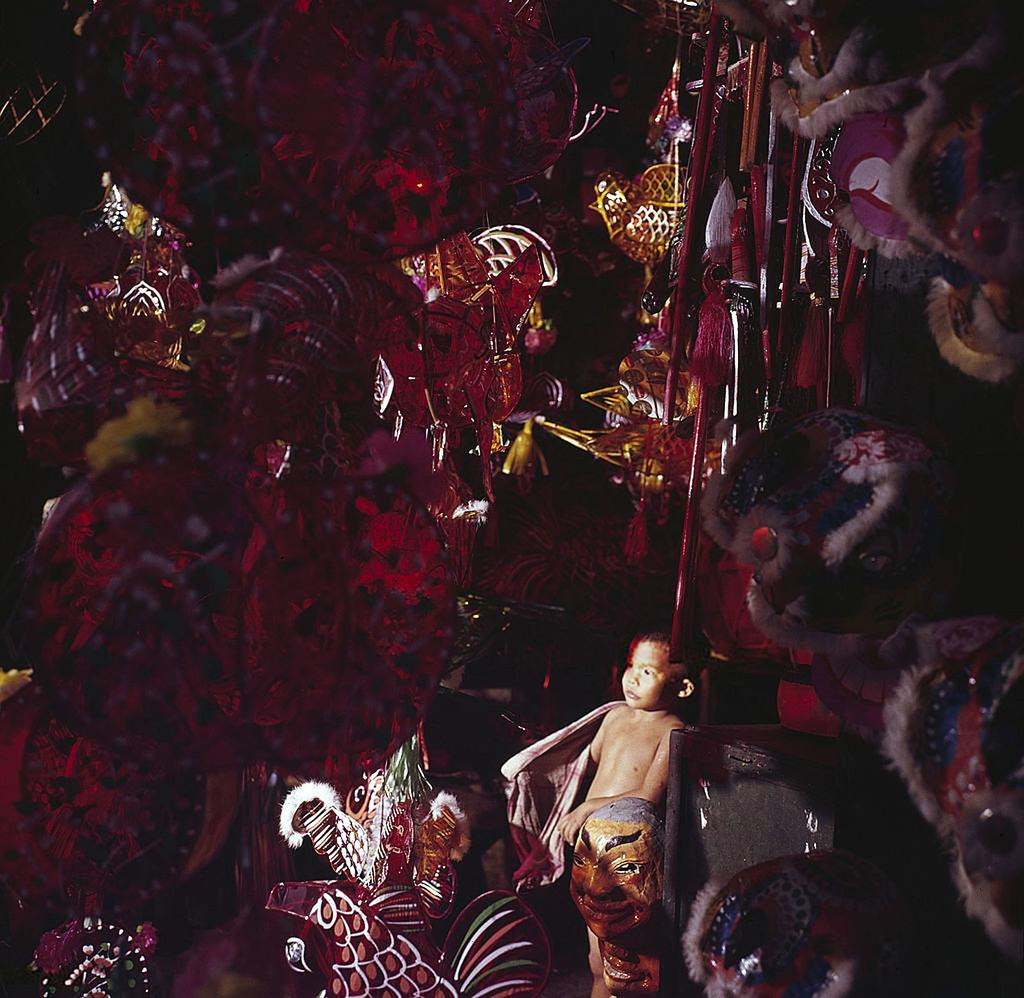Who is the main subject in the image? There is a boy in the middle of the image. What can be seen behind the boy? There are toys visible behind the boy. What is hanging at the top of the image? There are hangings at the top of the image. Where can the boy be seen helping someone in the image? There is no indication in the image that the boy is helping someone, so it cannot be determined from the picture. 